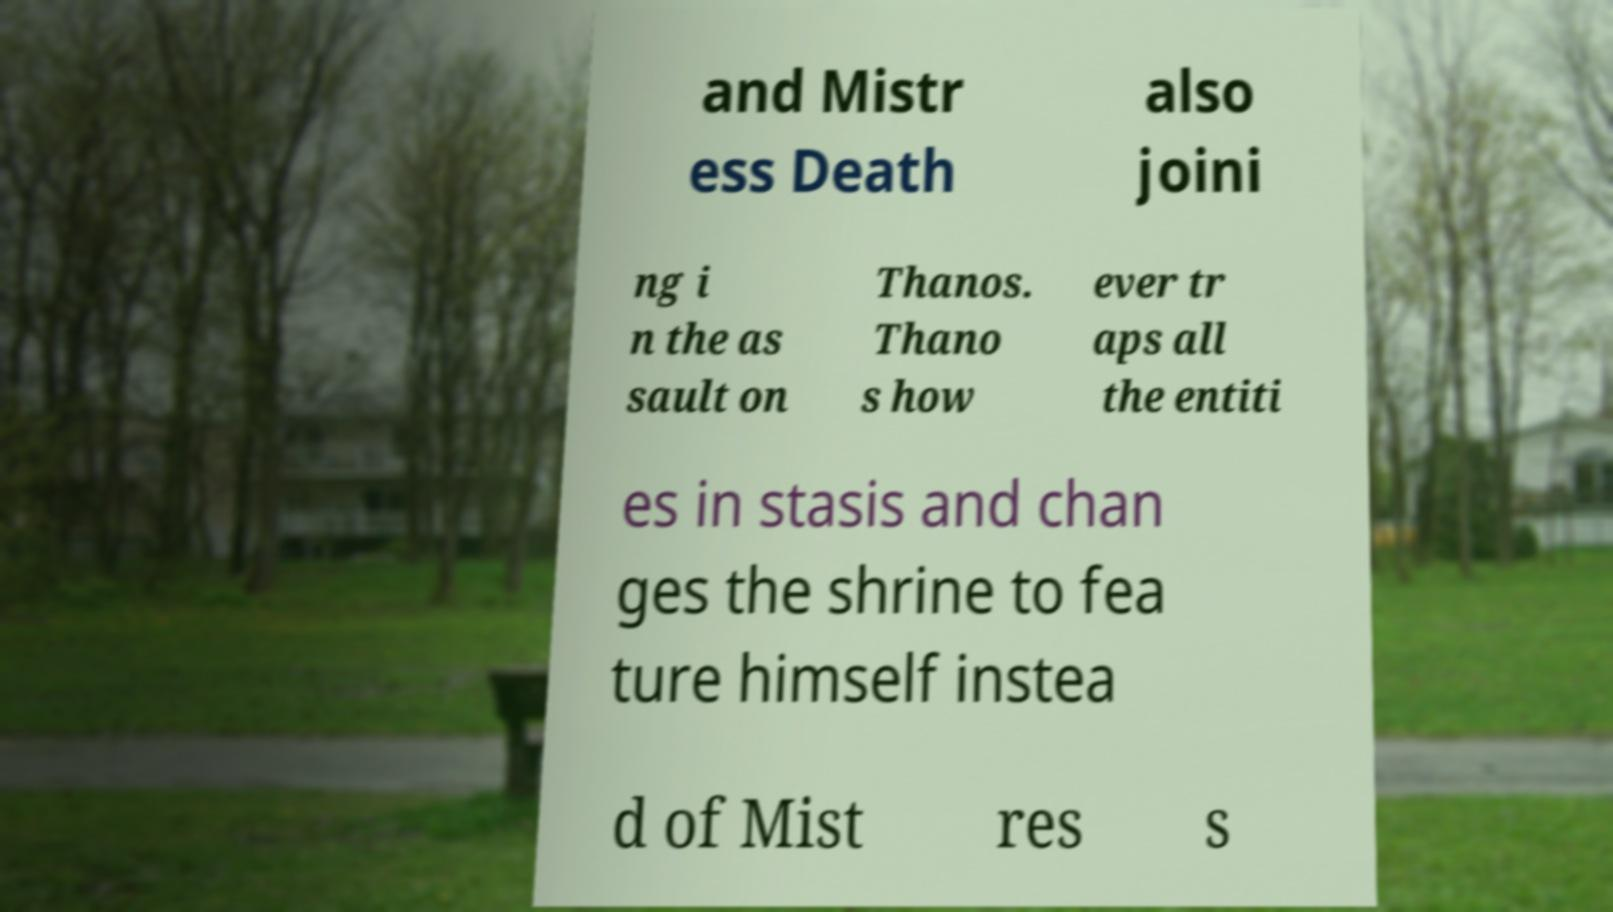Could you extract and type out the text from this image? and Mistr ess Death also joini ng i n the as sault on Thanos. Thano s how ever tr aps all the entiti es in stasis and chan ges the shrine to fea ture himself instea d of Mist res s 